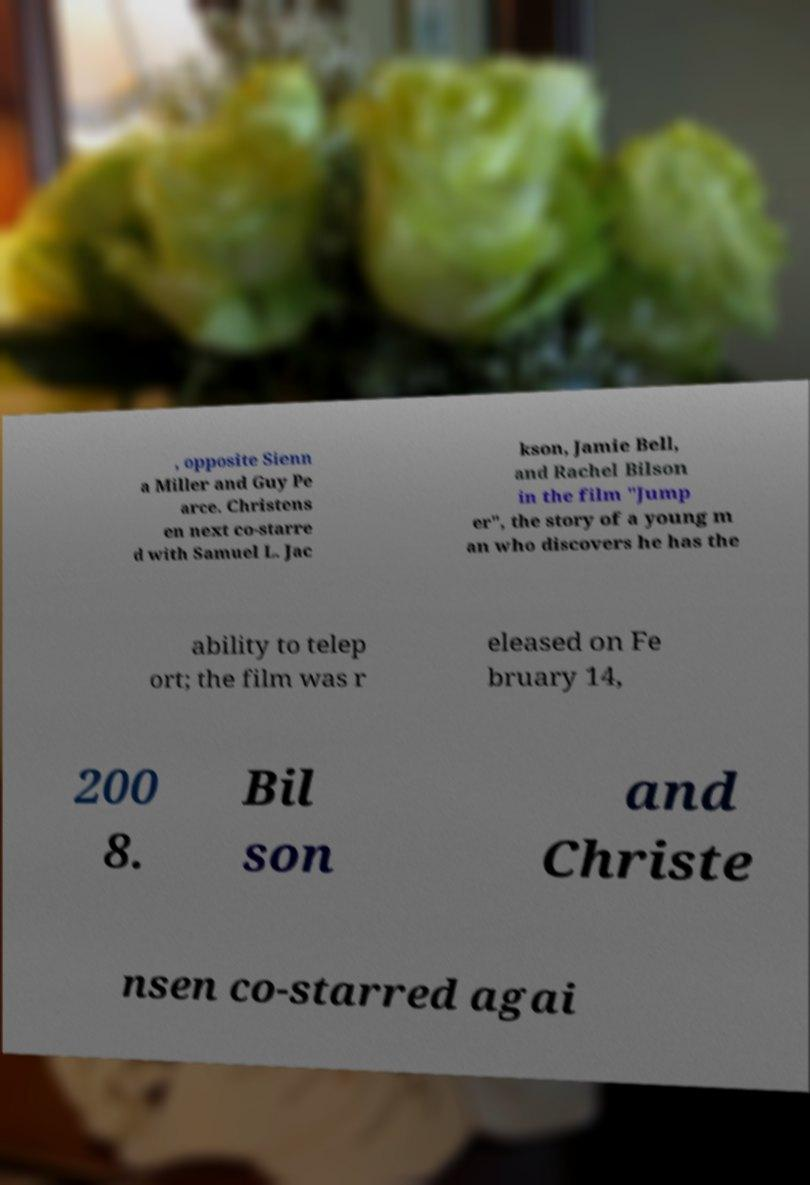What messages or text are displayed in this image? I need them in a readable, typed format. , opposite Sienn a Miller and Guy Pe arce. Christens en next co-starre d with Samuel L. Jac kson, Jamie Bell, and Rachel Bilson in the film "Jump er", the story of a young m an who discovers he has the ability to telep ort; the film was r eleased on Fe bruary 14, 200 8. Bil son and Christe nsen co-starred agai 